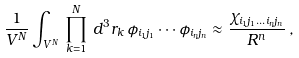<formula> <loc_0><loc_0><loc_500><loc_500>\frac { 1 } { V ^ { N } } \int _ { V ^ { N } } \, \prod _ { k = 1 } ^ { N } \, d ^ { 3 } r _ { k } \, \phi _ { i _ { 1 } j _ { 1 } } \cdots \phi _ { i _ { n } j _ { n } } \approx \frac { \chi _ { i _ { 1 } j _ { 1 } \dots i _ { n } j _ { n } } } { R ^ { n } } \, ,</formula> 